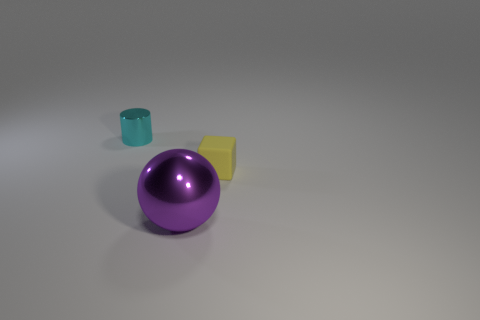What number of objects are either small things left of the yellow cube or big purple things?
Your response must be concise. 2. Is there anything else that has the same color as the tiny metallic thing?
Provide a short and direct response. No. There is a metal thing that is in front of the cyan cylinder; what is its size?
Provide a succinct answer. Large. There is a metal ball; is its color the same as the small object that is to the right of the big purple metal ball?
Keep it short and to the point. No. How many other objects are the same material as the purple ball?
Your response must be concise. 1. Are there more green rubber things than purple spheres?
Provide a succinct answer. No. Do the tiny thing to the left of the tiny yellow matte thing and the large sphere have the same color?
Offer a terse response. No. The shiny sphere is what color?
Give a very brief answer. Purple. There is a shiny object that is behind the yellow rubber thing; is there a small yellow block to the left of it?
Your response must be concise. No. There is a small object that is to the right of the object behind the block; what is its shape?
Make the answer very short. Cube. 